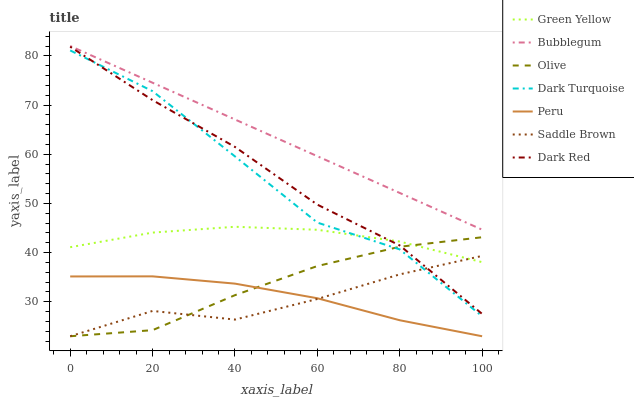Does Saddle Brown have the minimum area under the curve?
Answer yes or no. Yes. Does Bubblegum have the maximum area under the curve?
Answer yes or no. Yes. Does Peru have the minimum area under the curve?
Answer yes or no. No. Does Peru have the maximum area under the curve?
Answer yes or no. No. Is Bubblegum the smoothest?
Answer yes or no. Yes. Is Dark Turquoise the roughest?
Answer yes or no. Yes. Is Peru the smoothest?
Answer yes or no. No. Is Peru the roughest?
Answer yes or no. No. Does Bubblegum have the lowest value?
Answer yes or no. No. Does Bubblegum have the highest value?
Answer yes or no. Yes. Does Peru have the highest value?
Answer yes or no. No. Is Peru less than Green Yellow?
Answer yes or no. Yes. Is Green Yellow greater than Peru?
Answer yes or no. Yes. Does Olive intersect Green Yellow?
Answer yes or no. Yes. Is Olive less than Green Yellow?
Answer yes or no. No. Is Olive greater than Green Yellow?
Answer yes or no. No. Does Peru intersect Green Yellow?
Answer yes or no. No. 